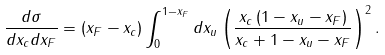<formula> <loc_0><loc_0><loc_500><loc_500>\frac { d \sigma } { d x _ { c } d x _ { F } } = \left ( x _ { F } - x _ { c } \right ) \int _ { 0 } ^ { 1 - x _ { F } } d x _ { u } \left ( \frac { x _ { c } \left ( 1 - x _ { u } - x _ { F } \right ) } { x _ { c } + 1 - x _ { u } - x _ { F } } \right ) ^ { 2 } .</formula> 